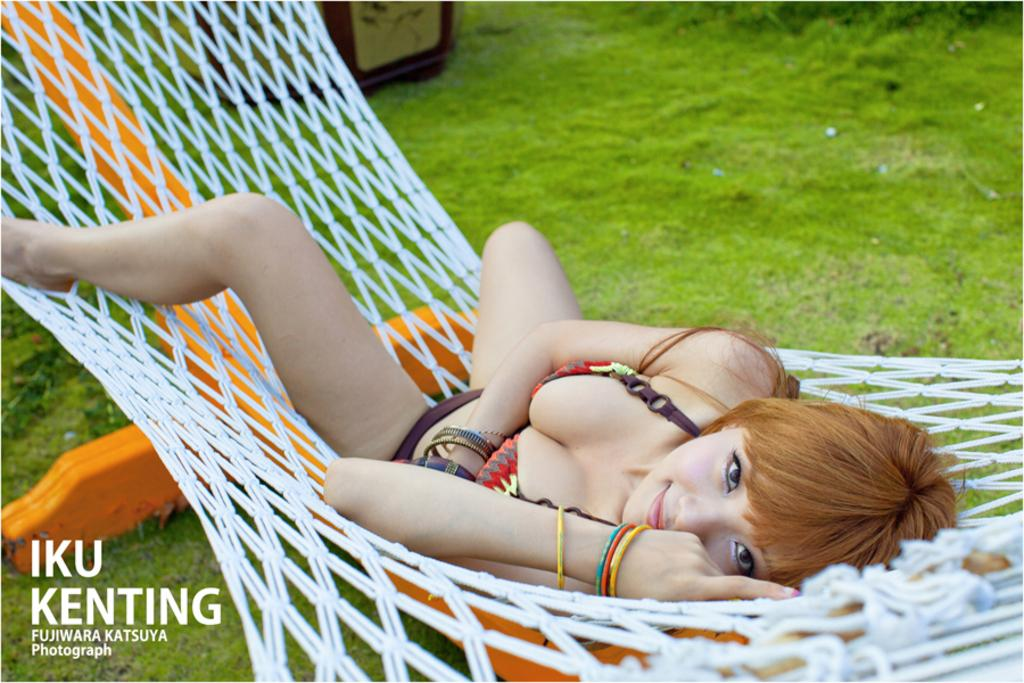What is the person in the image doing? The person is lying on a net in the image. What can be seen on the ground in the image? The ground is covered with grass and objects. Where is the text located in the image? The text is in the bottom left corner of the image. How many girls are playing with the mice on the roof in the image? There are no girls or mice present in the image, and there is no roof visible. 